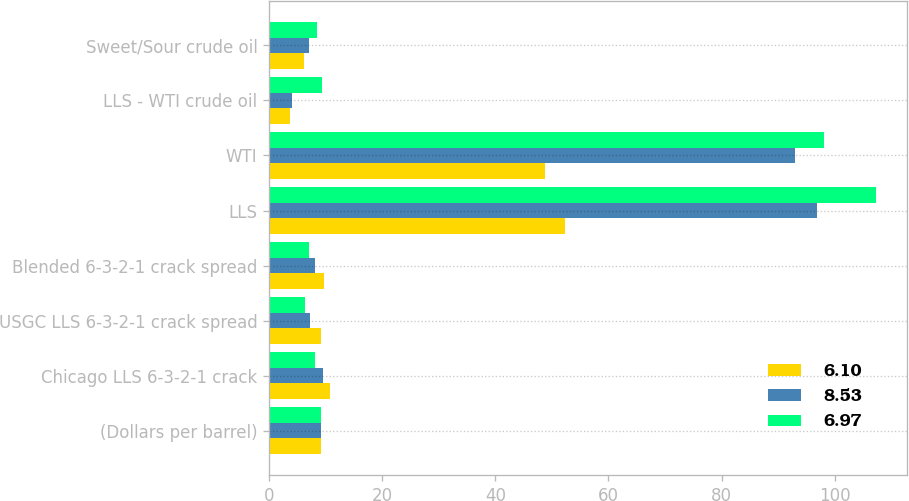<chart> <loc_0><loc_0><loc_500><loc_500><stacked_bar_chart><ecel><fcel>(Dollars per barrel)<fcel>Chicago LLS 6-3-2-1 crack<fcel>USGC LLS 6-3-2-1 crack spread<fcel>Blended 6-3-2-1 crack spread<fcel>LLS<fcel>WTI<fcel>LLS - WTI crude oil<fcel>Sweet/Sour crude oil<nl><fcel>6.1<fcel>9.11<fcel>10.67<fcel>9.11<fcel>9.7<fcel>52.35<fcel>48.76<fcel>3.59<fcel>6.1<nl><fcel>8.53<fcel>9.11<fcel>9.56<fcel>7.23<fcel>8.11<fcel>96.9<fcel>92.91<fcel>3.99<fcel>6.97<nl><fcel>6.97<fcel>9.11<fcel>8.16<fcel>6.24<fcel>6.97<fcel>107.38<fcel>98.05<fcel>9.33<fcel>8.53<nl></chart> 